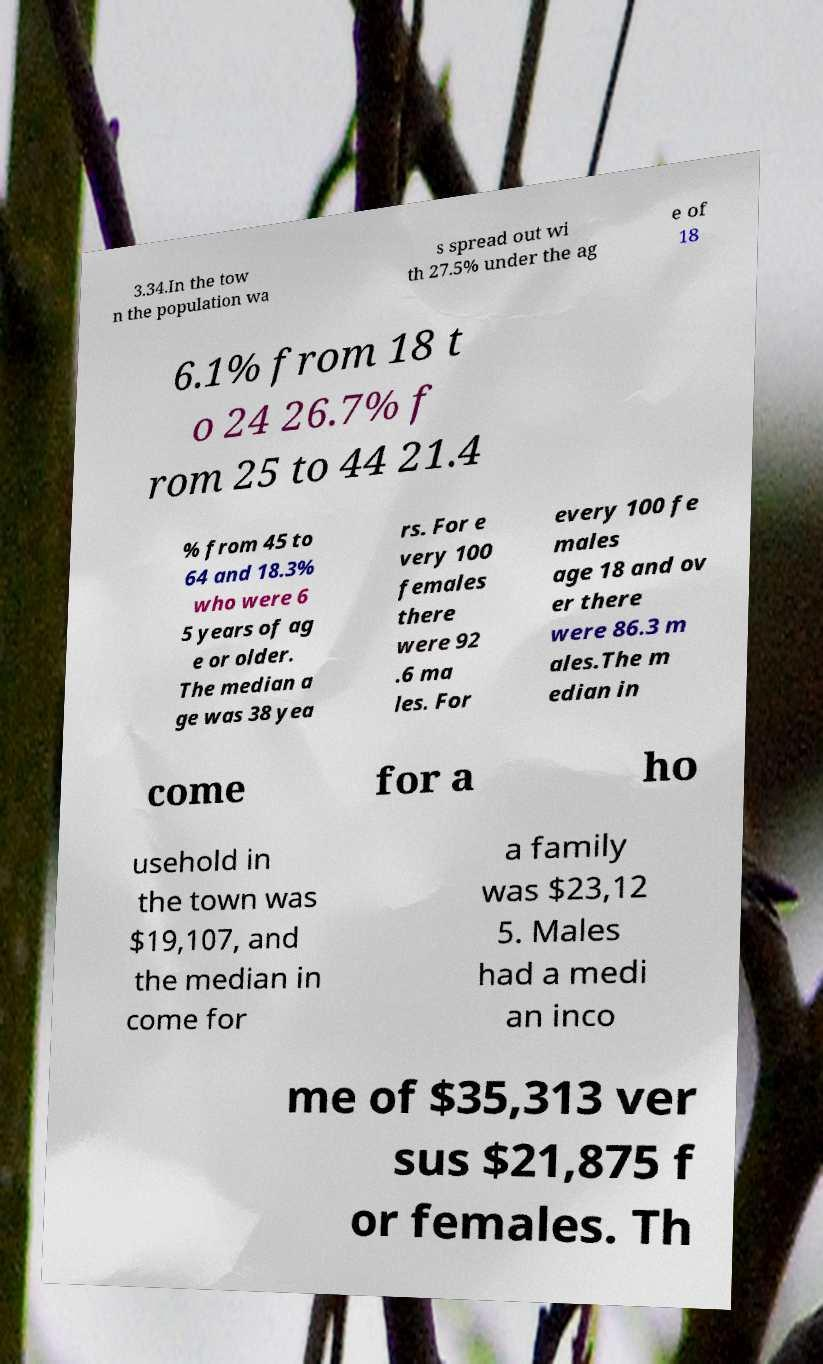Can you read and provide the text displayed in the image?This photo seems to have some interesting text. Can you extract and type it out for me? 3.34.In the tow n the population wa s spread out wi th 27.5% under the ag e of 18 6.1% from 18 t o 24 26.7% f rom 25 to 44 21.4 % from 45 to 64 and 18.3% who were 6 5 years of ag e or older. The median a ge was 38 yea rs. For e very 100 females there were 92 .6 ma les. For every 100 fe males age 18 and ov er there were 86.3 m ales.The m edian in come for a ho usehold in the town was $19,107, and the median in come for a family was $23,12 5. Males had a medi an inco me of $35,313 ver sus $21,875 f or females. Th 